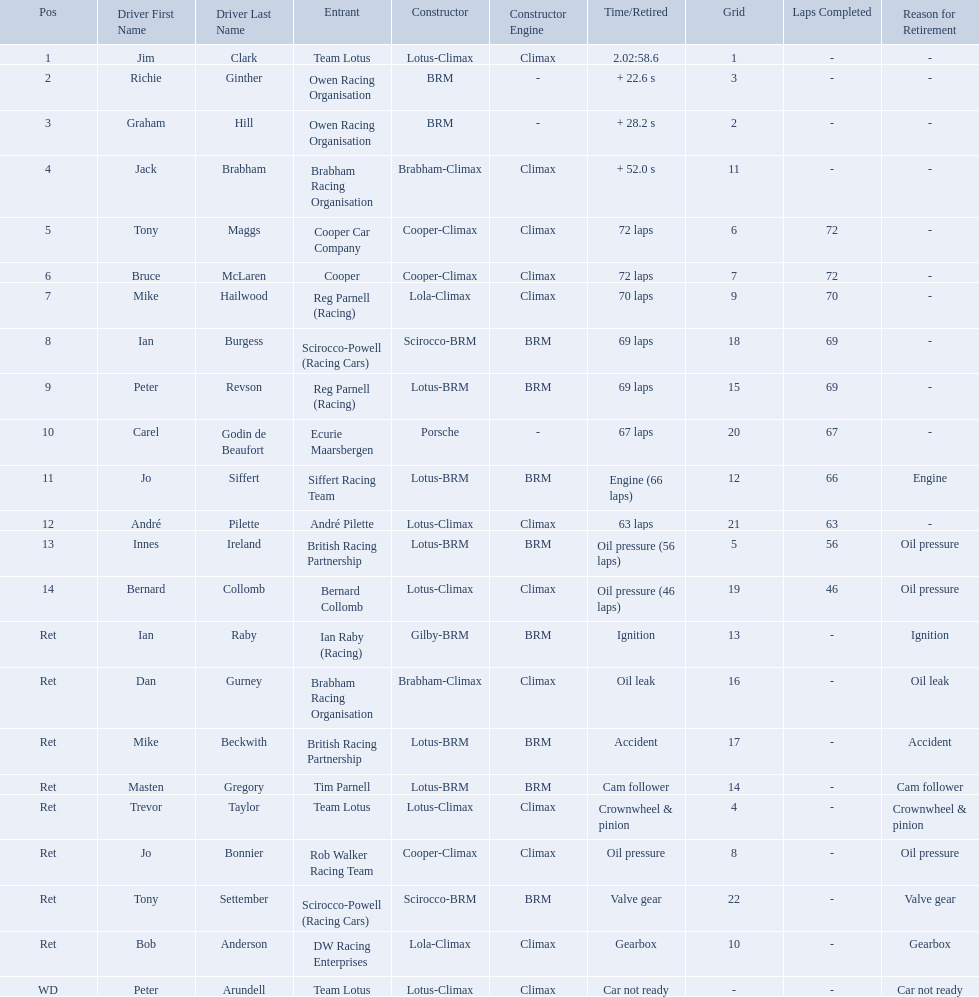Write the full table. {'header': ['Pos', 'Driver First Name', 'Driver Last Name', 'Entrant', 'Constructor', 'Constructor Engine', 'Time/Retired', 'Grid', 'Laps Completed', 'Reason for Retirement'], 'rows': [['1', 'Jim', 'Clark', 'Team Lotus', 'Lotus-Climax', 'Climax', '2.02:58.6', '1', '-', '-'], ['2', 'Richie', 'Ginther', 'Owen Racing Organisation', 'BRM', '-', '+ 22.6 s', '3', '-', '-'], ['3', 'Graham', 'Hill', 'Owen Racing Organisation', 'BRM', '-', '+ 28.2 s', '2', '-', '-'], ['4', 'Jack', 'Brabham', 'Brabham Racing Organisation', 'Brabham-Climax', 'Climax', '+ 52.0 s', '11', '-', '-'], ['5', 'Tony', 'Maggs', 'Cooper Car Company', 'Cooper-Climax', 'Climax', '72 laps', '6', '72', '-'], ['6', 'Bruce', 'McLaren', 'Cooper', 'Cooper-Climax', 'Climax', '72 laps', '7', '72', '-'], ['7', 'Mike', 'Hailwood', 'Reg Parnell (Racing)', 'Lola-Climax', 'Climax', '70 laps', '9', '70', '-'], ['8', 'Ian', 'Burgess', 'Scirocco-Powell (Racing Cars)', 'Scirocco-BRM', 'BRM', '69 laps', '18', '69', '-'], ['9', 'Peter', 'Revson', 'Reg Parnell (Racing)', 'Lotus-BRM', 'BRM', '69 laps', '15', '69', '-'], ['10', 'Carel', 'Godin de Beaufort', 'Ecurie Maarsbergen', 'Porsche', '-', '67 laps', '20', '67', '-'], ['11', 'Jo', 'Siffert', 'Siffert Racing Team', 'Lotus-BRM', 'BRM', 'Engine (66 laps)', '12', '66', 'Engine'], ['12', 'André', 'Pilette', 'André Pilette', 'Lotus-Climax', 'Climax', '63 laps', '21', '63', '-'], ['13', 'Innes', 'Ireland', 'British Racing Partnership', 'Lotus-BRM', 'BRM', 'Oil pressure (56 laps)', '5', '56', 'Oil pressure'], ['14', 'Bernard', 'Collomb', 'Bernard Collomb', 'Lotus-Climax', 'Climax', 'Oil pressure (46 laps)', '19', '46', 'Oil pressure'], ['Ret', 'Ian', 'Raby', 'Ian Raby (Racing)', 'Gilby-BRM', 'BRM', 'Ignition', '13', '-', 'Ignition'], ['Ret', 'Dan', 'Gurney', 'Brabham Racing Organisation', 'Brabham-Climax', 'Climax', 'Oil leak', '16', '-', 'Oil leak'], ['Ret', 'Mike', 'Beckwith', 'British Racing Partnership', 'Lotus-BRM', 'BRM', 'Accident', '17', '-', 'Accident'], ['Ret', 'Masten', 'Gregory', 'Tim Parnell', 'Lotus-BRM', 'BRM', 'Cam follower', '14', '-', 'Cam follower'], ['Ret', 'Trevor', 'Taylor', 'Team Lotus', 'Lotus-Climax', 'Climax', 'Crownwheel & pinion', '4', '-', 'Crownwheel & pinion'], ['Ret', 'Jo', 'Bonnier', 'Rob Walker Racing Team', 'Cooper-Climax', 'Climax', 'Oil pressure', '8', '-', 'Oil pressure'], ['Ret', 'Tony', 'Settember', 'Scirocco-Powell (Racing Cars)', 'Scirocco-BRM', 'BRM', 'Valve gear', '22', '-', 'Valve gear'], ['Ret', 'Bob', 'Anderson', 'DW Racing Enterprises', 'Lola-Climax', 'Climax', 'Gearbox', '10', '-', 'Gearbox'], ['WD', 'Peter', 'Arundell', 'Team Lotus', 'Lotus-Climax', 'Climax', 'Car not ready', '-', '-', 'Car not ready']]} Who are all the drivers? Jim Clark, Richie Ginther, Graham Hill, Jack Brabham, Tony Maggs, Bruce McLaren, Mike Hailwood, Ian Burgess, Peter Revson, Carel Godin de Beaufort, Jo Siffert, André Pilette, Innes Ireland, Bernard Collomb, Ian Raby, Dan Gurney, Mike Beckwith, Masten Gregory, Trevor Taylor, Jo Bonnier, Tony Settember, Bob Anderson, Peter Arundell. What position were they in? 1, 2, 3, 4, 5, 6, 7, 8, 9, 10, 11, 12, 13, 14, Ret, Ret, Ret, Ret, Ret, Ret, Ret, Ret, WD. What about just tony maggs and jo siffert? 5, 11. And between them, which driver came in earlier? Tony Maggs. Who were the drivers at the 1963 international gold cup? Jim Clark, Richie Ginther, Graham Hill, Jack Brabham, Tony Maggs, Bruce McLaren, Mike Hailwood, Ian Burgess, Peter Revson, Carel Godin de Beaufort, Jo Siffert, André Pilette, Innes Ireland, Bernard Collomb, Ian Raby, Dan Gurney, Mike Beckwith, Masten Gregory, Trevor Taylor, Jo Bonnier, Tony Settember, Bob Anderson, Peter Arundell. What was tony maggs position? 5. What was jo siffert? 11. Who came in earlier? Tony Maggs. What are the listed driver names? Jim Clark, Richie Ginther, Graham Hill, Jack Brabham, Tony Maggs, Bruce McLaren, Mike Hailwood, Ian Burgess, Peter Revson, Carel Godin de Beaufort, Jo Siffert, André Pilette, Innes Ireland, Bernard Collomb, Ian Raby, Dan Gurney, Mike Beckwith, Masten Gregory, Trevor Taylor, Jo Bonnier, Tony Settember, Bob Anderson, Peter Arundell. Which are tony maggs and jo siffert? Tony Maggs, Jo Siffert. What are their corresponding finishing places? 5, 11. Whose is better? Tony Maggs. Who were the drivers in the the 1963 international gold cup? Jim Clark, Richie Ginther, Graham Hill, Jack Brabham, Tony Maggs, Bruce McLaren, Mike Hailwood, Ian Burgess, Peter Revson, Carel Godin de Beaufort, Jo Siffert, André Pilette, Innes Ireland, Bernard Collomb, Ian Raby, Dan Gurney, Mike Beckwith, Masten Gregory, Trevor Taylor, Jo Bonnier, Tony Settember, Bob Anderson, Peter Arundell. Which drivers drove a cooper-climax car? Tony Maggs, Bruce McLaren, Jo Bonnier. What did these drivers place? 5, 6, Ret. What was the best placing position? 5. Who was the driver with this placing? Tony Maggs. Who all drive cars that were constructed bur climax? Jim Clark, Jack Brabham, Tony Maggs, Bruce McLaren, Mike Hailwood, André Pilette, Bernard Collomb, Dan Gurney, Trevor Taylor, Jo Bonnier, Bob Anderson, Peter Arundell. Which driver's climax constructed cars started in the top 10 on the grid? Jim Clark, Tony Maggs, Bruce McLaren, Mike Hailwood, Jo Bonnier, Bob Anderson. Of the top 10 starting climax constructed drivers, which ones did not finish the race? Jo Bonnier, Bob Anderson. What was the failure that was engine related that took out the driver of the climax constructed car that did not finish even though it started in the top 10? Oil pressure. Who were the two that that a similar problem? Innes Ireland. What was their common problem? Oil pressure. 